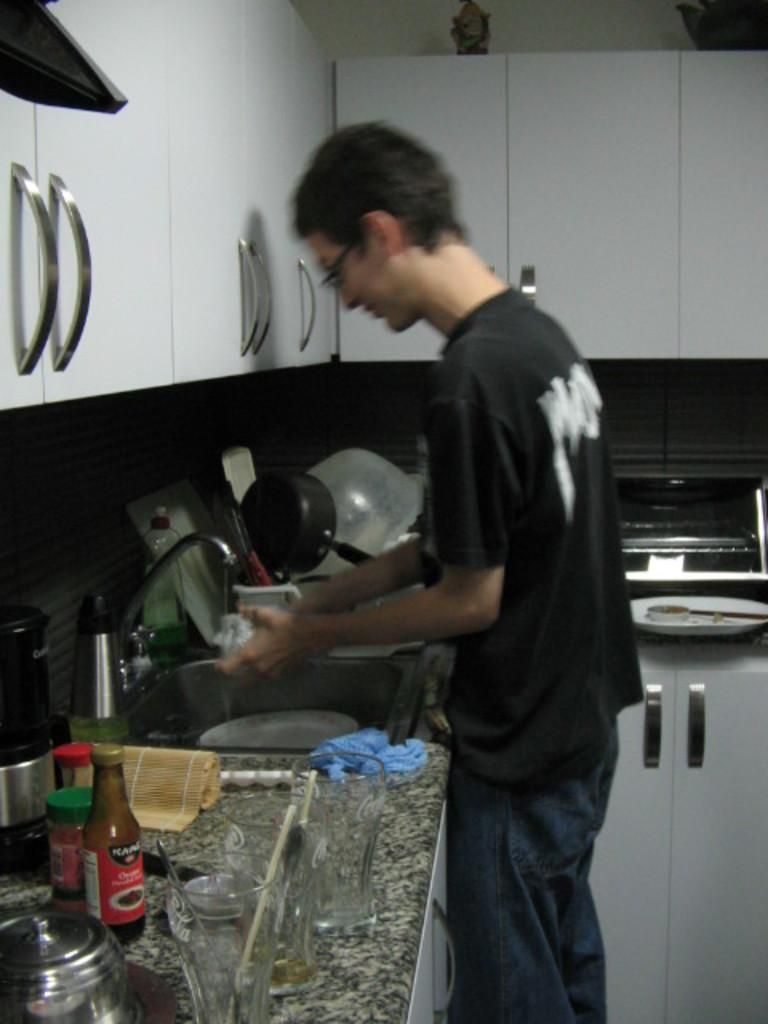What is the man in the kitchen doing? The man is standing and washing dishes. Where is the man located in the kitchen? The man is near the sink. What types of items can be seen in the image? There are bottles, dishes, and glasses visible in the image. What can be seen in the background of the image? There are cupboards in the background of the image. How many passengers are visible in the image? There are no passengers present in the image; it is a man in a kitchen washing dishes. What type of writing instrument is the man using in the image? There is no writing instrument present in the image; the man is washing dishes. 